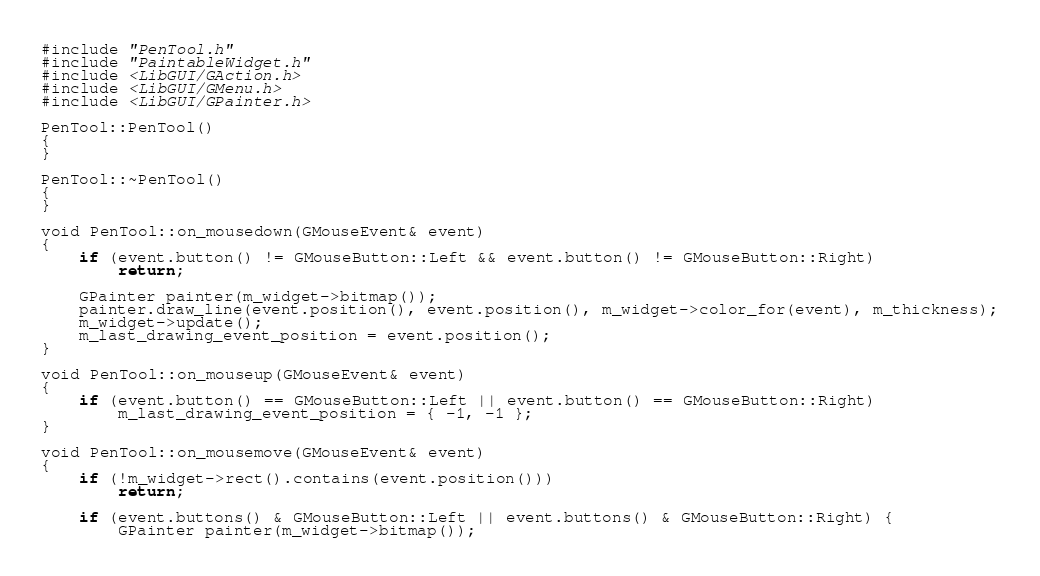<code> <loc_0><loc_0><loc_500><loc_500><_C++_>#include "PenTool.h"
#include "PaintableWidget.h"
#include <LibGUI/GAction.h>
#include <LibGUI/GMenu.h>
#include <LibGUI/GPainter.h>

PenTool::PenTool()
{
}

PenTool::~PenTool()
{
}

void PenTool::on_mousedown(GMouseEvent& event)
{
    if (event.button() != GMouseButton::Left && event.button() != GMouseButton::Right)
        return;

    GPainter painter(m_widget->bitmap());
    painter.draw_line(event.position(), event.position(), m_widget->color_for(event), m_thickness);
    m_widget->update();
    m_last_drawing_event_position = event.position();
}

void PenTool::on_mouseup(GMouseEvent& event)
{
    if (event.button() == GMouseButton::Left || event.button() == GMouseButton::Right)
        m_last_drawing_event_position = { -1, -1 };
}

void PenTool::on_mousemove(GMouseEvent& event)
{
    if (!m_widget->rect().contains(event.position()))
        return;

    if (event.buttons() & GMouseButton::Left || event.buttons() & GMouseButton::Right) {
        GPainter painter(m_widget->bitmap());
</code> 